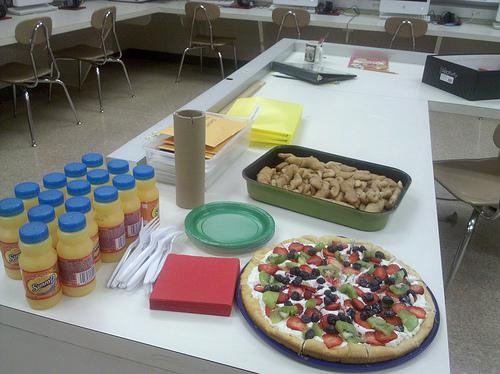Question: what color are the plates?
Choices:
A. Blue.
B. Yellow.
C. Red.
D. Green.
Answer with the letter. Answer: D Question: where is this scene?
Choices:
A. Cubicle.
B. Conference room.
C. Break room.
D. An office.
Answer with the letter. Answer: D Question: when is it?
Choices:
A. Breakfast time.
B. Lunch time.
C. Dinner time.
D. Supper time.
Answer with the letter. Answer: A Question: what is on the pizza?
Choices:
A. Pepperoni.
B. Sausage.
C. Fruit.
D. Pineapple.
Answer with the letter. Answer: C Question: how many pizzas are there?
Choices:
A. 2.
B. 1.
C. 3.
D. 6.
Answer with the letter. Answer: B 